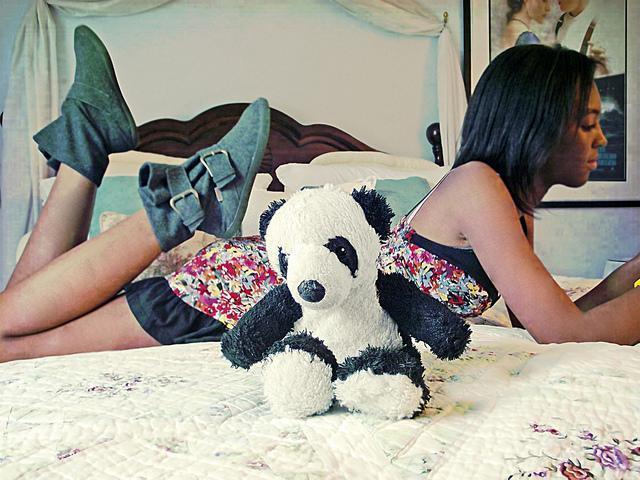How many people are in the photo?
Give a very brief answer. 1. How many beds are visible?
Give a very brief answer. 1. How many people can you see?
Give a very brief answer. 2. How many black dogs are in the image?
Give a very brief answer. 0. 